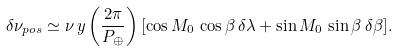<formula> <loc_0><loc_0><loc_500><loc_500>\delta \nu _ { p o s } \simeq \nu \, y \left ( \frac { 2 \pi } { P _ { \oplus } } \right ) [ \cos { M _ { 0 } } \, \cos { \beta } \, \delta \lambda + \sin { M _ { 0 } } \, \sin { \beta } \, \delta \beta ] .</formula> 